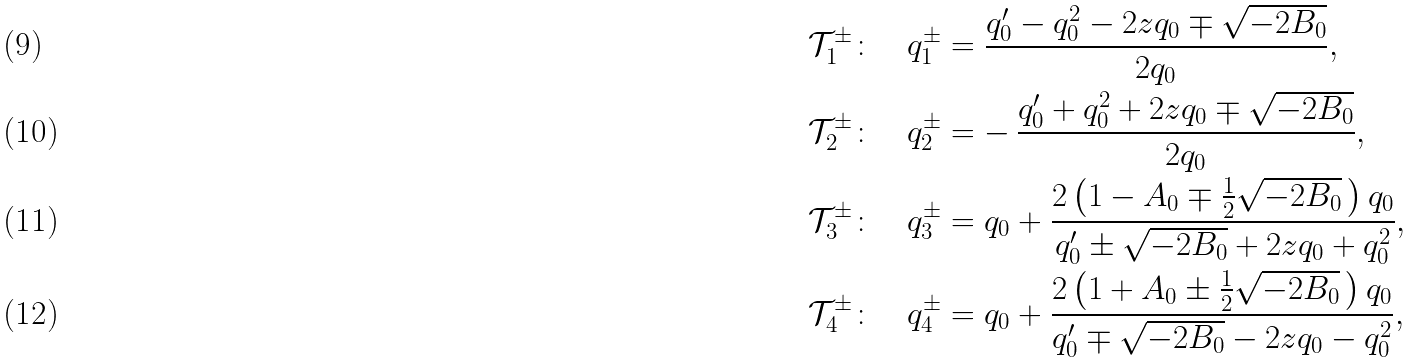Convert formula to latex. <formula><loc_0><loc_0><loc_500><loc_500>\mathcal { T } _ { 1 } ^ { \pm } \colon \quad q _ { 1 } ^ { \pm } & = \frac { q _ { 0 } ^ { \prime } - q _ { 0 } ^ { 2 } - 2 z q _ { 0 } \mp \sqrt { - 2 B _ { 0 } } } { 2 q _ { 0 } } , \\ \mathcal { T } _ { 2 } ^ { \pm } \colon \quad q _ { 2 } ^ { \pm } & = - \, \frac { q _ { 0 } ^ { \prime } + q _ { 0 } ^ { 2 } + 2 z q _ { 0 } \mp \sqrt { - 2 B _ { 0 } } } { 2 q _ { 0 } } , \\ \mathcal { T } _ { 3 } ^ { \pm } \colon \quad q _ { 3 } ^ { \pm } & = q _ { 0 } + \frac { 2 \left ( 1 - A _ { 0 } \mp \frac { 1 } { 2 } \sqrt { - 2 B _ { 0 } } \, \right ) q _ { 0 } } { q _ { 0 } ^ { \prime } \pm \sqrt { - 2 B _ { 0 } } + 2 z q _ { 0 } + q _ { 0 } ^ { 2 } } , \\ \mathcal { T } _ { 4 } ^ { \pm } \colon \quad q _ { 4 } ^ { \pm } & = q _ { 0 } + \frac { 2 \left ( 1 + A _ { 0 } \pm \frac { 1 } { 2 } \sqrt { - 2 B _ { 0 } } \, \right ) q _ { 0 } } { q _ { 0 } ^ { \prime } \mp \sqrt { - 2 B _ { 0 } } - 2 z q _ { 0 } - q _ { 0 } ^ { 2 } } ,</formula> 